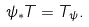<formula> <loc_0><loc_0><loc_500><loc_500>\psi _ { * } T = T _ { \psi } .</formula> 